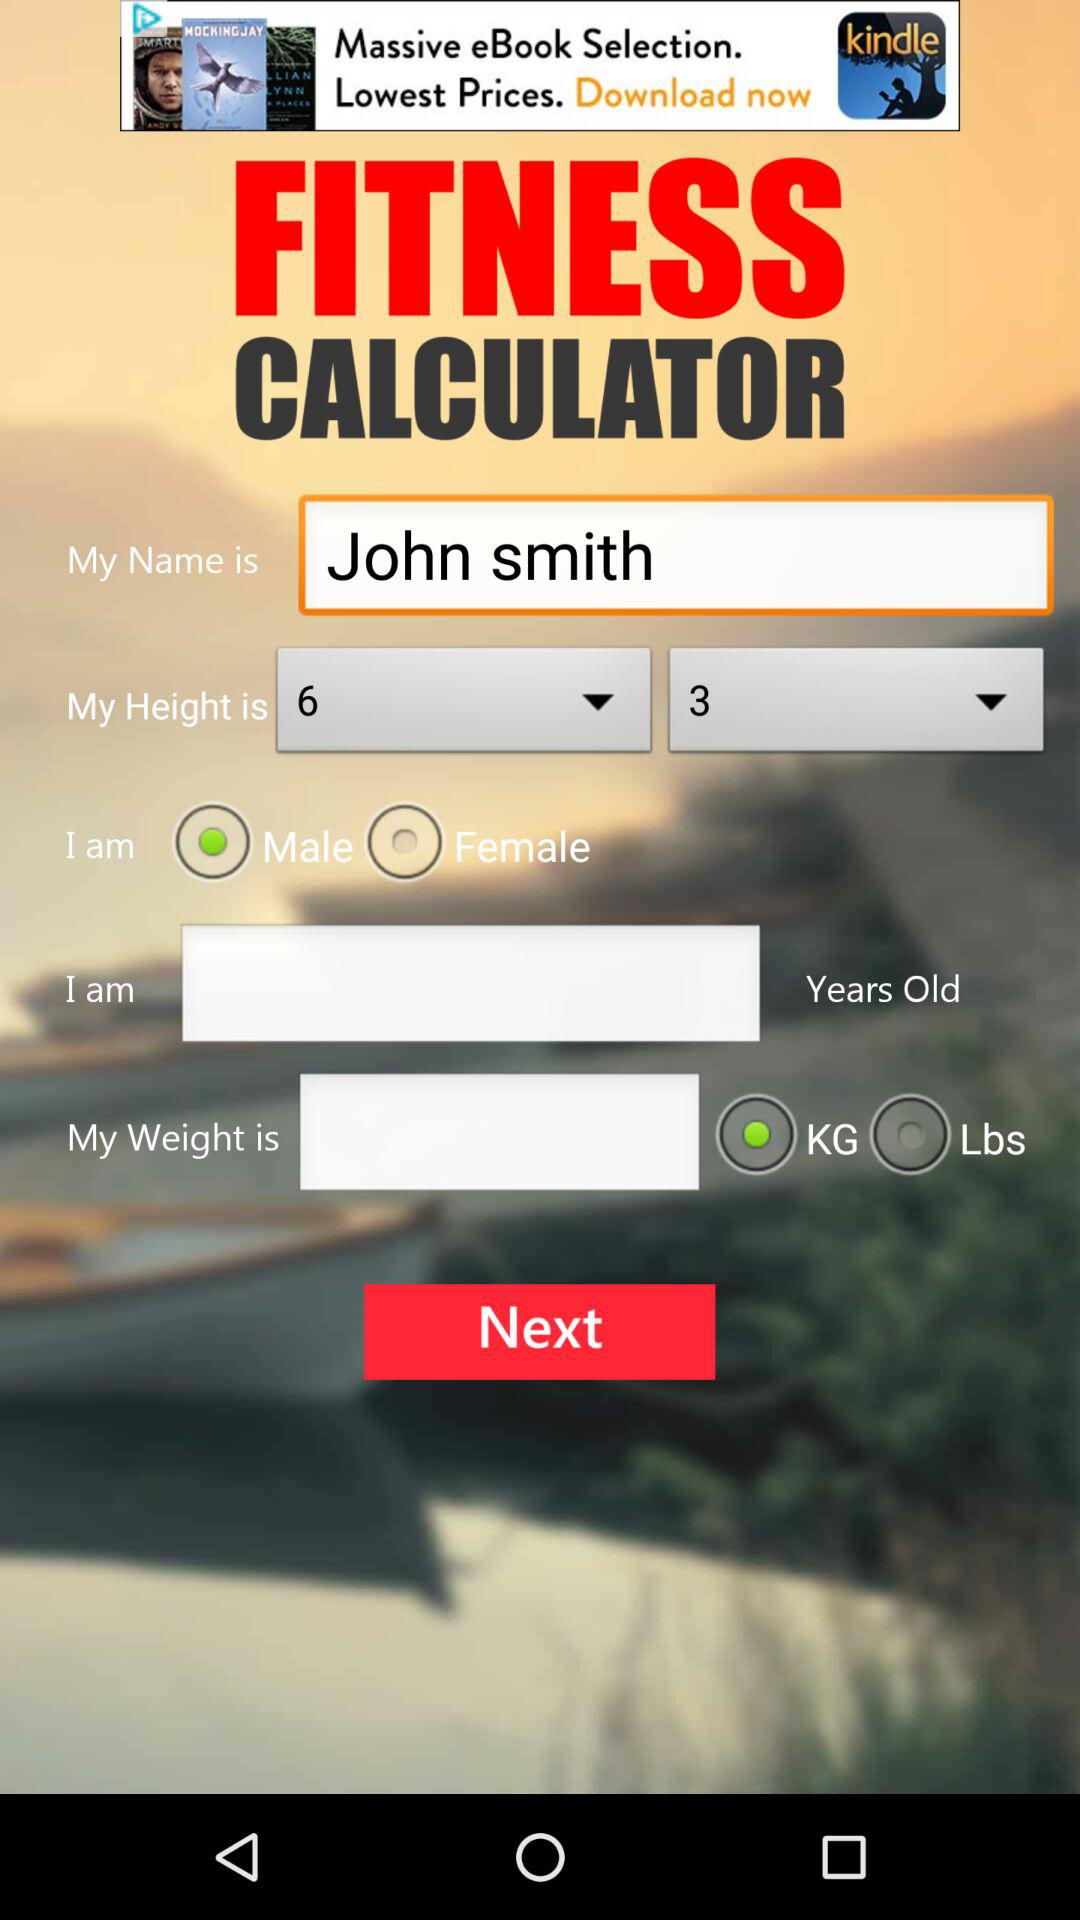What is the app's name? The app's name is "FITNESS CALCULATOR". 